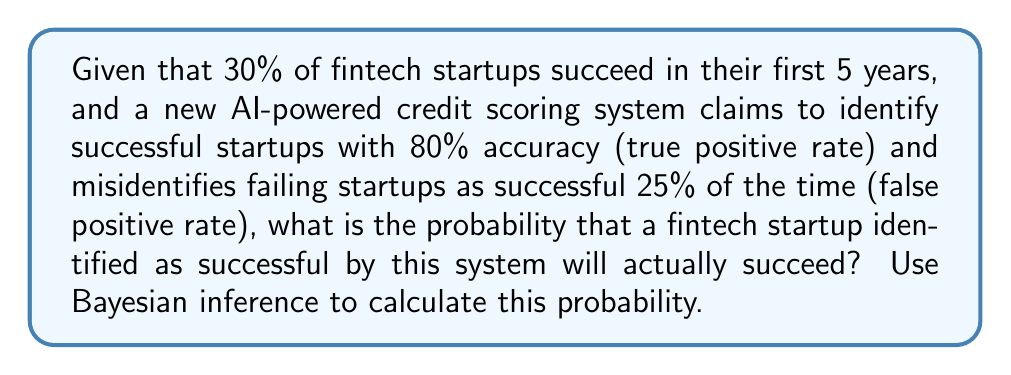Help me with this question. Let's approach this problem using Bayesian inference:

1) Define our events:
   S: Startup succeeds
   P: Startup is predicted to succeed by the AI system

2) Given information:
   P(S) = 0.30 (prior probability of success)
   P(P|S) = 0.80 (true positive rate)
   P(P|not S) = 0.25 (false positive rate)

3) We want to find P(S|P) using Bayes' theorem:

   $$P(S|P) = \frac{P(P|S) \cdot P(S)}{P(P)}$$

4) Calculate P(P) using the law of total probability:
   
   $$P(P) = P(P|S) \cdot P(S) + P(P|not S) \cdot P(not S)$$
   $$P(P) = 0.80 \cdot 0.30 + 0.25 \cdot 0.70 = 0.24 + 0.175 = 0.415$$

5) Now we can apply Bayes' theorem:

   $$P(S|P) = \frac{0.80 \cdot 0.30}{0.415} = \frac{0.24}{0.415} \approx 0.5783$$

6) Convert to percentage: 0.5783 * 100% ≈ 57.83%

Therefore, the probability that a fintech startup identified as successful by this AI system will actually succeed is approximately 57.83%.
Answer: 57.83% 